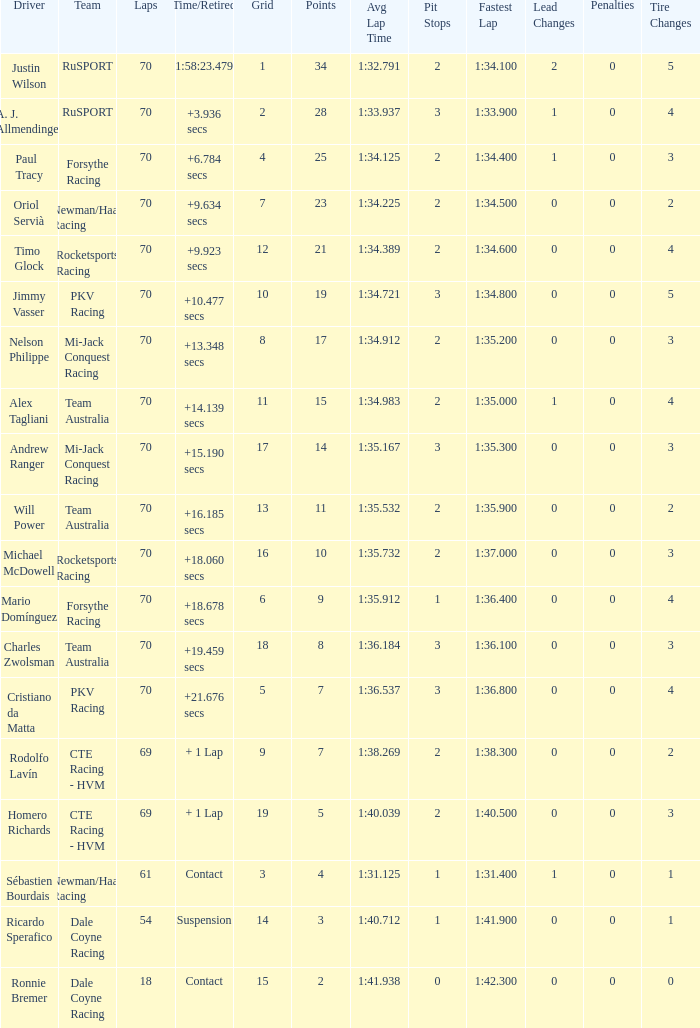Who scored with a grid of 10 and the highest amount of laps? 70.0. 